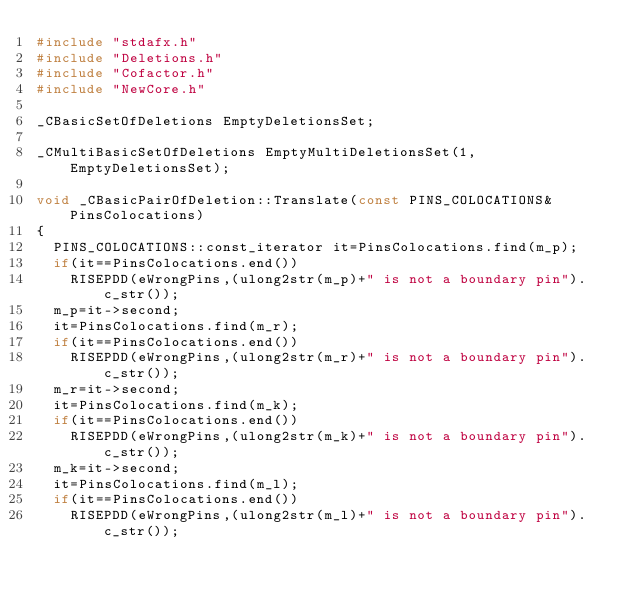<code> <loc_0><loc_0><loc_500><loc_500><_C++_>#include "stdafx.h"
#include "Deletions.h"
#include "Cofactor.h"
#include "NewCore.h"

_CBasicSetOfDeletions EmptyDeletionsSet;

_CMultiBasicSetOfDeletions EmptyMultiDeletionsSet(1, EmptyDeletionsSet);

void _CBasicPairOfDeletion::Translate(const PINS_COLOCATIONS& PinsColocations)
{
	PINS_COLOCATIONS::const_iterator it=PinsColocations.find(m_p);
	if(it==PinsColocations.end())
		RISEPDD(eWrongPins,(ulong2str(m_p)+" is not a boundary pin").c_str());
	m_p=it->second;
	it=PinsColocations.find(m_r);
	if(it==PinsColocations.end())
		RISEPDD(eWrongPins,(ulong2str(m_r)+" is not a boundary pin").c_str());
	m_r=it->second;
	it=PinsColocations.find(m_k);
	if(it==PinsColocations.end())
		RISEPDD(eWrongPins,(ulong2str(m_k)+" is not a boundary pin").c_str());
	m_k=it->second;
	it=PinsColocations.find(m_l);
	if(it==PinsColocations.end())
		RISEPDD(eWrongPins,(ulong2str(m_l)+" is not a boundary pin").c_str());</code> 